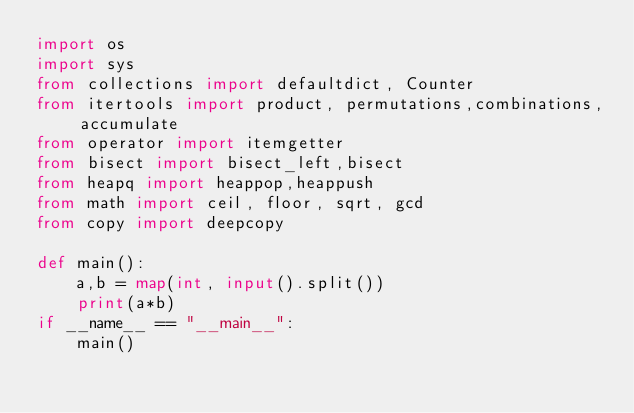Convert code to text. <code><loc_0><loc_0><loc_500><loc_500><_Python_>import os
import sys
from collections import defaultdict, Counter
from itertools import product, permutations,combinations, accumulate
from operator import itemgetter
from bisect import bisect_left,bisect
from heapq import heappop,heappush
from math import ceil, floor, sqrt, gcd
from copy import deepcopy

def main():
    a,b = map(int, input().split())
    print(a*b)
if __name__ == "__main__":
    main()</code> 